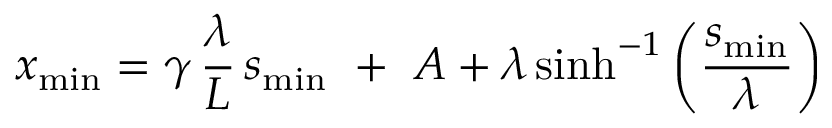<formula> <loc_0><loc_0><loc_500><loc_500>x _ { \min } = \gamma \, \frac { \lambda } { L } \, s _ { \min } + A + \lambda \sinh ^ { - 1 } \left ( \frac { s _ { \min } } { \lambda } \right )</formula> 